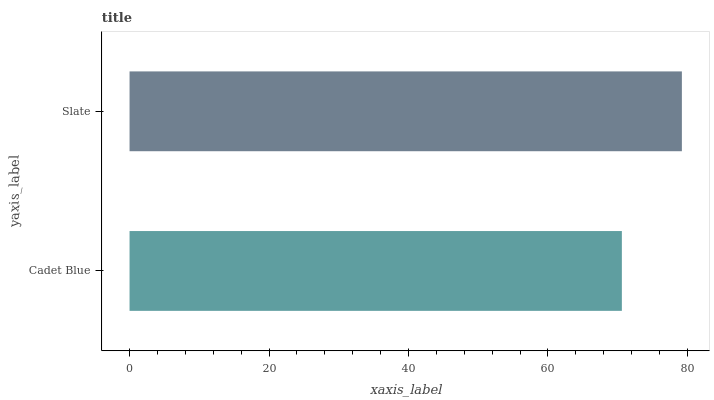Is Cadet Blue the minimum?
Answer yes or no. Yes. Is Slate the maximum?
Answer yes or no. Yes. Is Slate the minimum?
Answer yes or no. No. Is Slate greater than Cadet Blue?
Answer yes or no. Yes. Is Cadet Blue less than Slate?
Answer yes or no. Yes. Is Cadet Blue greater than Slate?
Answer yes or no. No. Is Slate less than Cadet Blue?
Answer yes or no. No. Is Slate the high median?
Answer yes or no. Yes. Is Cadet Blue the low median?
Answer yes or no. Yes. Is Cadet Blue the high median?
Answer yes or no. No. Is Slate the low median?
Answer yes or no. No. 